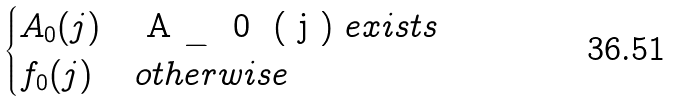Convert formula to latex. <formula><loc_0><loc_0><loc_500><loc_500>\begin{cases} A _ { 0 } ( j ) & $ A _ { 0 } ( j ) $ e x i s t s \\ f _ { 0 } ( j ) & o t h e r w i s e \end{cases}</formula> 